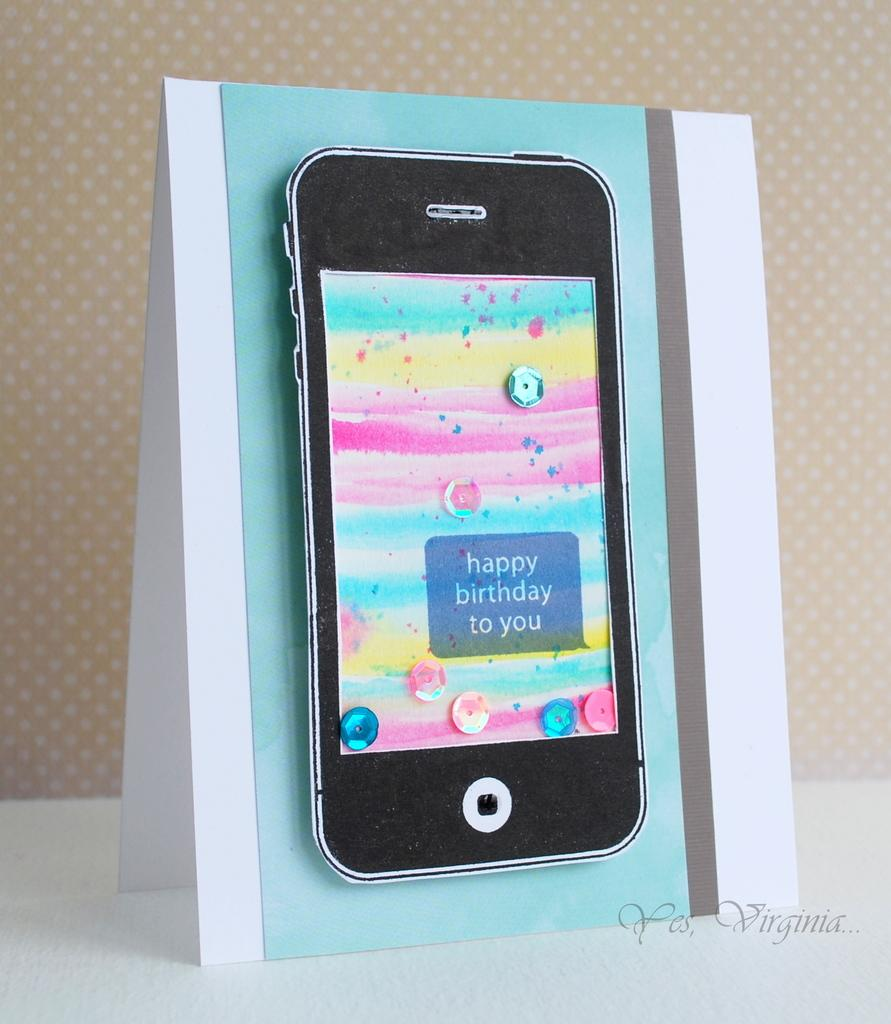<image>
Create a compact narrative representing the image presented. A card that has the image of a phone that says happy birthday to you on it. 